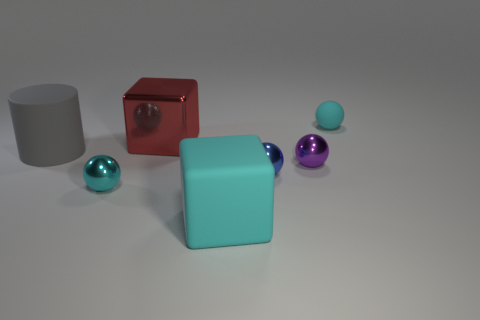Do the cube that is behind the large cylinder and the small cyan ball that is right of the small purple object have the same material? Upon visually examining the objects in the image, the cube behind the large cylinder displays a matte surface, suggesting a non-reflective material. In contrast, the small cyan ball to the right of the small purple object has a shiny surface, indicating a reflective material, most likely a gloss finish. Therefore, they do not have the same material properties. 